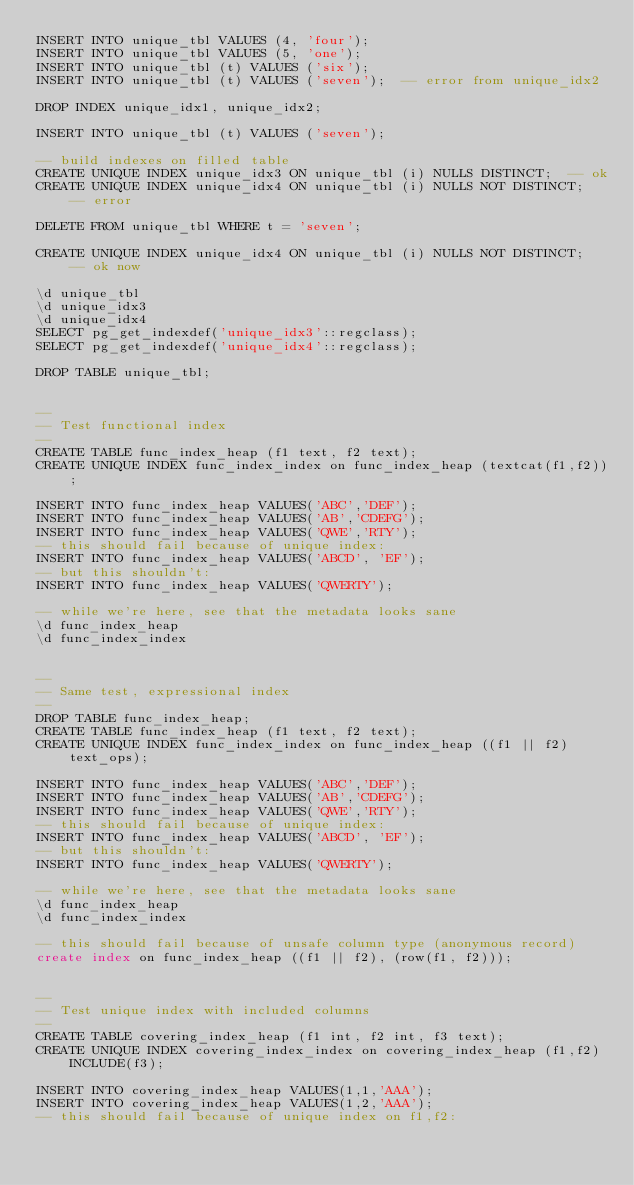Convert code to text. <code><loc_0><loc_0><loc_500><loc_500><_SQL_>INSERT INTO unique_tbl VALUES (4, 'four');
INSERT INTO unique_tbl VALUES (5, 'one');
INSERT INTO unique_tbl (t) VALUES ('six');
INSERT INTO unique_tbl (t) VALUES ('seven');  -- error from unique_idx2

DROP INDEX unique_idx1, unique_idx2;

INSERT INTO unique_tbl (t) VALUES ('seven');

-- build indexes on filled table
CREATE UNIQUE INDEX unique_idx3 ON unique_tbl (i) NULLS DISTINCT;  -- ok
CREATE UNIQUE INDEX unique_idx4 ON unique_tbl (i) NULLS NOT DISTINCT;  -- error

DELETE FROM unique_tbl WHERE t = 'seven';

CREATE UNIQUE INDEX unique_idx4 ON unique_tbl (i) NULLS NOT DISTINCT;  -- ok now

\d unique_tbl
\d unique_idx3
\d unique_idx4
SELECT pg_get_indexdef('unique_idx3'::regclass);
SELECT pg_get_indexdef('unique_idx4'::regclass);

DROP TABLE unique_tbl;


--
-- Test functional index
--
CREATE TABLE func_index_heap (f1 text, f2 text);
CREATE UNIQUE INDEX func_index_index on func_index_heap (textcat(f1,f2));

INSERT INTO func_index_heap VALUES('ABC','DEF');
INSERT INTO func_index_heap VALUES('AB','CDEFG');
INSERT INTO func_index_heap VALUES('QWE','RTY');
-- this should fail because of unique index:
INSERT INTO func_index_heap VALUES('ABCD', 'EF');
-- but this shouldn't:
INSERT INTO func_index_heap VALUES('QWERTY');

-- while we're here, see that the metadata looks sane
\d func_index_heap
\d func_index_index


--
-- Same test, expressional index
--
DROP TABLE func_index_heap;
CREATE TABLE func_index_heap (f1 text, f2 text);
CREATE UNIQUE INDEX func_index_index on func_index_heap ((f1 || f2) text_ops);

INSERT INTO func_index_heap VALUES('ABC','DEF');
INSERT INTO func_index_heap VALUES('AB','CDEFG');
INSERT INTO func_index_heap VALUES('QWE','RTY');
-- this should fail because of unique index:
INSERT INTO func_index_heap VALUES('ABCD', 'EF');
-- but this shouldn't:
INSERT INTO func_index_heap VALUES('QWERTY');

-- while we're here, see that the metadata looks sane
\d func_index_heap
\d func_index_index

-- this should fail because of unsafe column type (anonymous record)
create index on func_index_heap ((f1 || f2), (row(f1, f2)));


--
-- Test unique index with included columns
--
CREATE TABLE covering_index_heap (f1 int, f2 int, f3 text);
CREATE UNIQUE INDEX covering_index_index on covering_index_heap (f1,f2) INCLUDE(f3);

INSERT INTO covering_index_heap VALUES(1,1,'AAA');
INSERT INTO covering_index_heap VALUES(1,2,'AAA');
-- this should fail because of unique index on f1,f2:</code> 